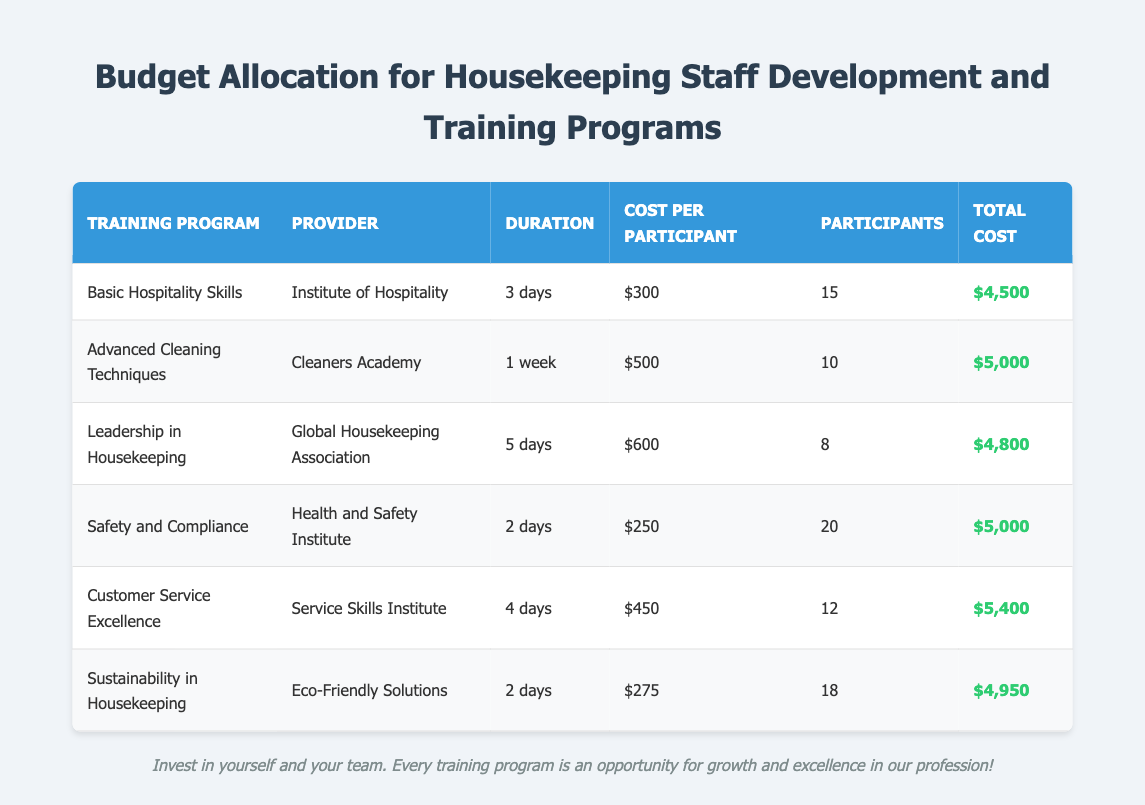What is the total cost for the "Basic Hospitality Skills" training program? The total cost is listed in the table under "Total Cost" for the corresponding row of the program. The value can be found as $4,500.
Answer: $4,500 How many participants are involved in the "Advanced Cleaning Techniques" training program? The number of participants is found in the row for the "Advanced Cleaning Techniques" program. It shows a value of 10.
Answer: 10 Which training program has the highest cost per participant? To determine this, compare the "Cost Per Participant" values in the table. The "Leadership in Housekeeping" has the highest value at $600.
Answer: Leadership in Housekeeping What is the average cost per participant across all programs? To find the average, sum all "Cost Per Participant" values: (300 + 500 + 600 + 250 + 450 + 275) = 2375. Then, divide by the number of programs (6), giving 2375 / 6 = approximately 395.83.
Answer: $395.83 Is the "Safety and Compliance" program less expensive than $300 per participant? The "Safety and Compliance" program costs $250 per participant, which is less than $300. Thus, the answer is yes.
Answer: Yes What is the total expenditure for all training programs combined? Adding up all "Total Cost" values from the table: (4500 + 5000 + 4800 + 5000 + 5400 + 4950) = 34650.
Answer: $34,650 Which training program provider offers the most participants? Check the number of participants for each program. "Safety and Compliance" has the highest involvement at 20 participants.
Answer: Health and Safety Institute If one were to attend all the programs offered, what would the total cost amount to? To find the amount, sum all the "Total Cost" values: 4500 + 5000 + 4800 + 5000 + 5400 + 4950 = 34650.
Answer: $34,650 How many programs have a duration of 2 days? Identify the duration for each program in the table. "Safety and Compliance" and "Sustainability in Housekeeping" are both 2 days, leading to a total of 2 programs.
Answer: 2 What percentage of the total budget is allocated to "Customer Service Excellence"? Calculate the total budget ($34,650). The cost for "Customer Service Excellence" is $5,400. The percentage is (5400 / 34650) * 100 ≈ 15.57%.
Answer: 15.57% 